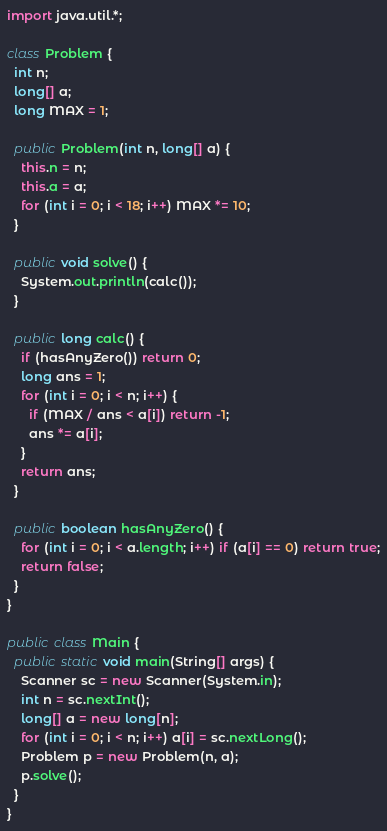Convert code to text. <code><loc_0><loc_0><loc_500><loc_500><_Java_>import java.util.*;

class Problem {
  int n;
  long[] a;
  long MAX = 1;
  
  public Problem(int n, long[] a) {
    this.n = n;
    this.a = a;
    for (int i = 0; i < 18; i++) MAX *= 10;
  }

  public void solve() {
    System.out.println(calc());
  }

  public long calc() {
    if (hasAnyZero()) return 0;
    long ans = 1;
    for (int i = 0; i < n; i++) {
      if (MAX / ans < a[i]) return -1;
      ans *= a[i];
    }
    return ans;
  }

  public boolean hasAnyZero() {
    for (int i = 0; i < a.length; i++) if (a[i] == 0) return true;
    return false;
  }
}

public class Main {
  public static void main(String[] args) {
    Scanner sc = new Scanner(System.in);
    int n = sc.nextInt();
    long[] a = new long[n];
    for (int i = 0; i < n; i++) a[i] = sc.nextLong();
    Problem p = new Problem(n, a);
    p.solve();
  }
}

</code> 